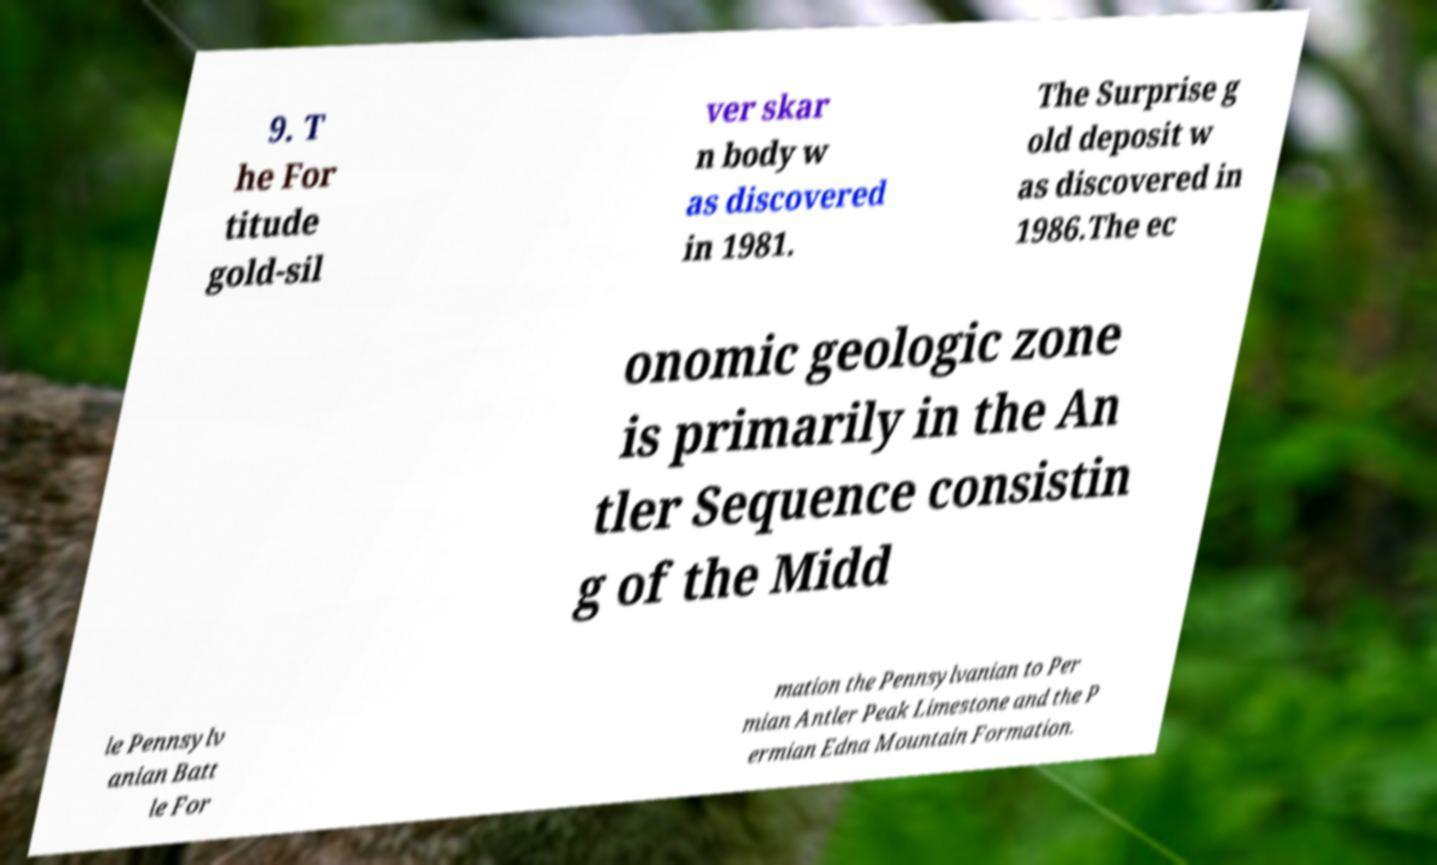Please read and relay the text visible in this image. What does it say? 9. T he For titude gold-sil ver skar n body w as discovered in 1981. The Surprise g old deposit w as discovered in 1986.The ec onomic geologic zone is primarily in the An tler Sequence consistin g of the Midd le Pennsylv anian Batt le For mation the Pennsylvanian to Per mian Antler Peak Limestone and the P ermian Edna Mountain Formation. 